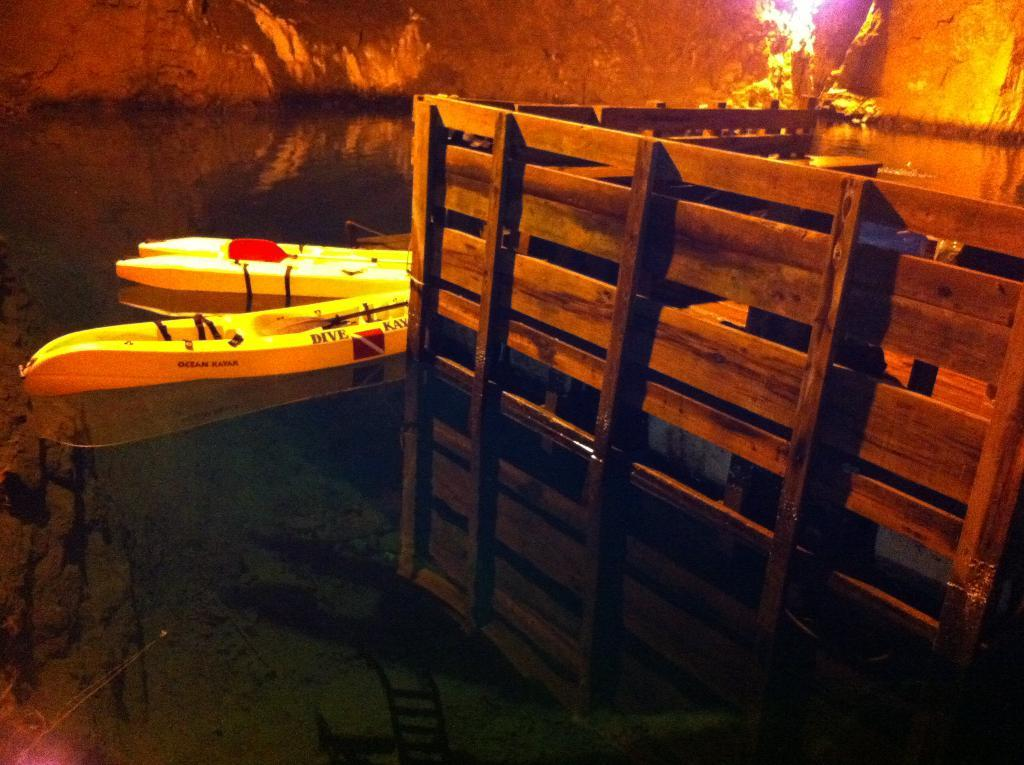What type of objects can be seen in the image? There are wooden objects in the image. What are the wooden objects used for? The wooden objects are likely used as boats, as boats are present in the image. How are the boats positioned in the image? The boats are above the water in the image. What can be seen at the top of the image? Rocks and light are visible at the top of the image. What effect can be observed on the water's surface? Reflections are visible on the water. What type of bait is being used by the trains in the image? There are no trains present in the image, so there is no bait being used. 